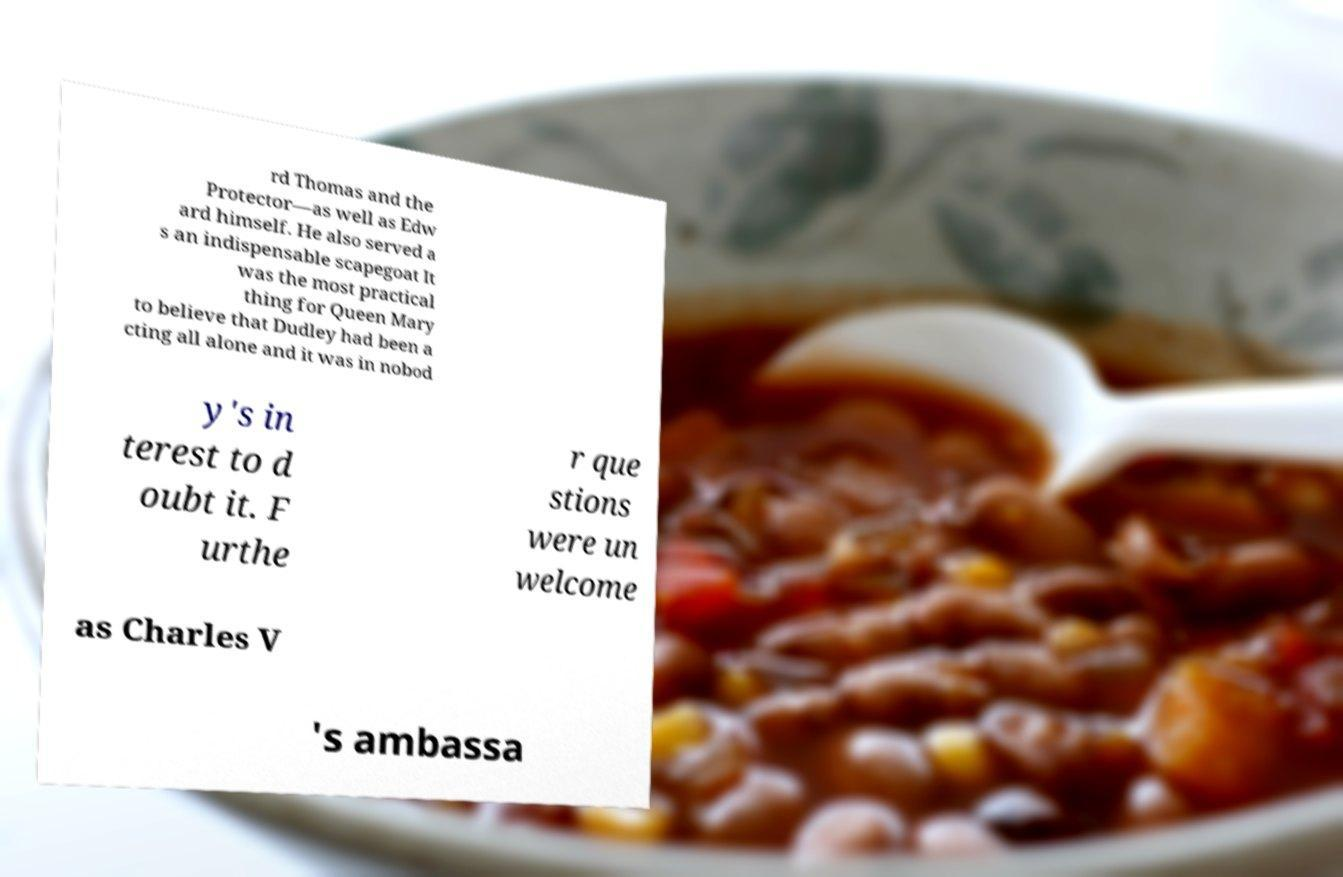I need the written content from this picture converted into text. Can you do that? rd Thomas and the Protector—as well as Edw ard himself. He also served a s an indispensable scapegoat It was the most practical thing for Queen Mary to believe that Dudley had been a cting all alone and it was in nobod y's in terest to d oubt it. F urthe r que stions were un welcome as Charles V 's ambassa 